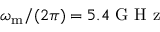<formula> <loc_0><loc_0><loc_500><loc_500>\omega _ { m } / ( 2 \pi ) = 5 . 4 G H z</formula> 